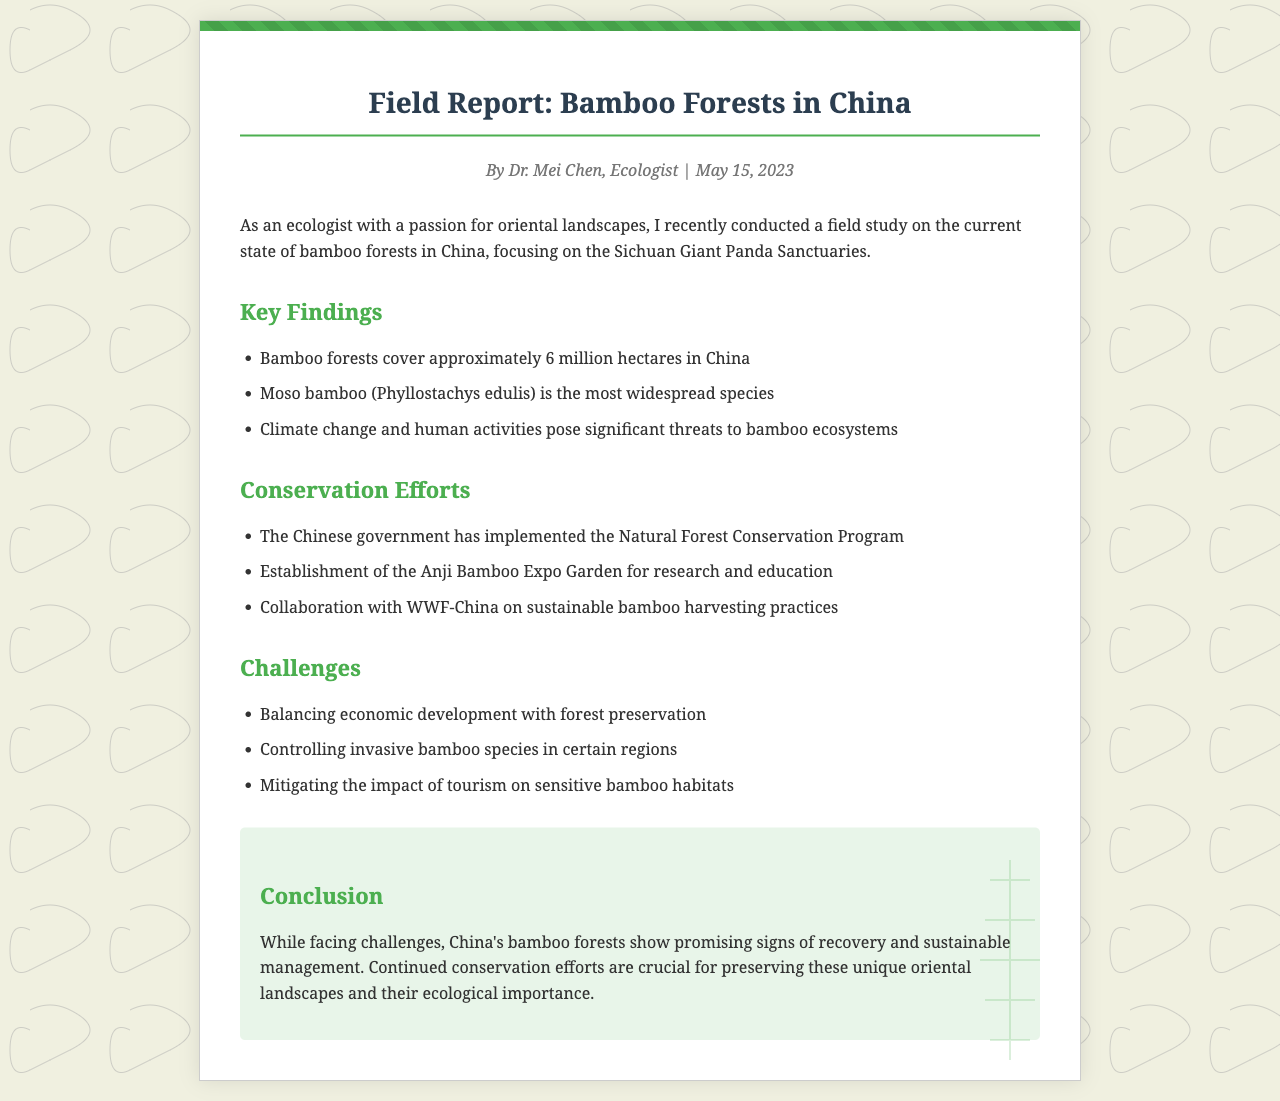What is the title of the report? The title of the report is presented at the top of the document.
Answer: Field Report: Bamboo Forests in China Who conducted the field study? The author of the report is mentioned in the header section.
Answer: Dr. Mei Chen When was the report published? The date of publication is also found in the meta section.
Answer: May 15, 2023 What is the most widespread species of bamboo in China? The document lists the most common species found in the bamboo forests.
Answer: Moso bamboo (Phyllostachys edulis) How many hectares do bamboo forests cover in China? The total area covered by bamboo forests is indicated in the key findings section.
Answer: 6 million hectares What conservation program has the Chinese government implemented? The report details various conservation efforts underway in China.
Answer: Natural Forest Conservation Program What challenges do the bamboo forests face? The document outlines several main challenges in a specific section.
Answer: Balancing economic development with forest preservation What is the conclusion about the current state of bamboo forests? The final thoughts of the report summarize the findings regarding bamboo forests.
Answer: Promising signs of recovery and sustainable management 